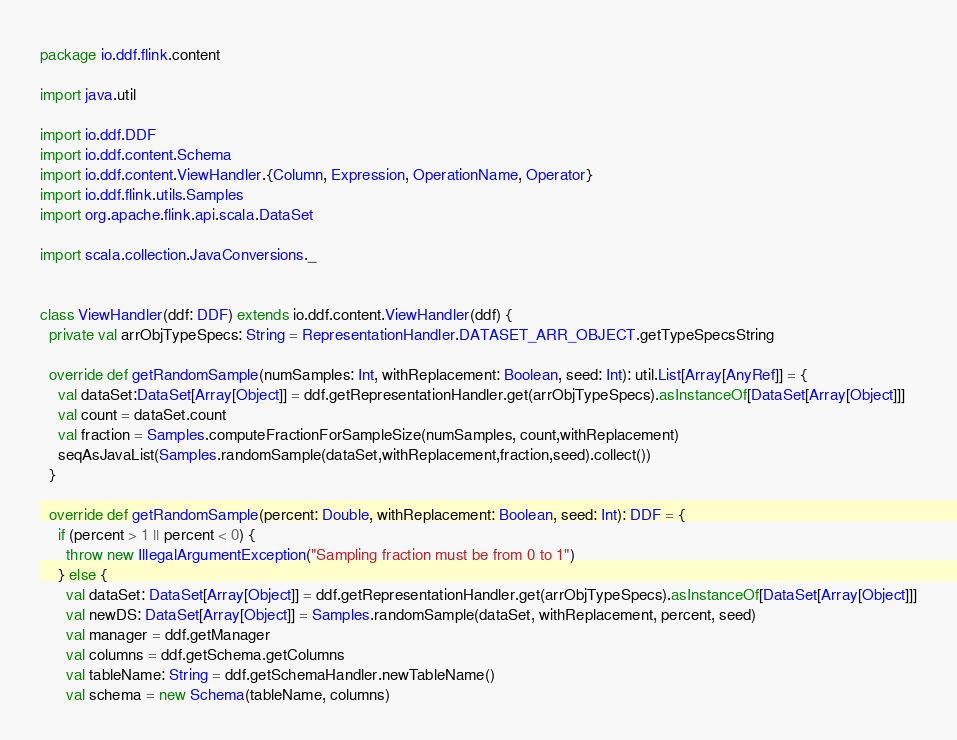<code> <loc_0><loc_0><loc_500><loc_500><_Scala_>package io.ddf.flink.content

import java.util

import io.ddf.DDF
import io.ddf.content.Schema
import io.ddf.content.ViewHandler.{Column, Expression, OperationName, Operator}
import io.ddf.flink.utils.Samples
import org.apache.flink.api.scala.DataSet

import scala.collection.JavaConversions._


class ViewHandler(ddf: DDF) extends io.ddf.content.ViewHandler(ddf) {
  private val arrObjTypeSpecs: String = RepresentationHandler.DATASET_ARR_OBJECT.getTypeSpecsString

  override def getRandomSample(numSamples: Int, withReplacement: Boolean, seed: Int): util.List[Array[AnyRef]] = {
    val dataSet:DataSet[Array[Object]] = ddf.getRepresentationHandler.get(arrObjTypeSpecs).asInstanceOf[DataSet[Array[Object]]]
    val count = dataSet.count
    val fraction = Samples.computeFractionForSampleSize(numSamples, count,withReplacement)
    seqAsJavaList(Samples.randomSample(dataSet,withReplacement,fraction,seed).collect())
  }

  override def getRandomSample(percent: Double, withReplacement: Boolean, seed: Int): DDF = {
    if (percent > 1 || percent < 0) {
      throw new IllegalArgumentException("Sampling fraction must be from 0 to 1")
    } else {
      val dataSet: DataSet[Array[Object]] = ddf.getRepresentationHandler.get(arrObjTypeSpecs).asInstanceOf[DataSet[Array[Object]]]
      val newDS: DataSet[Array[Object]] = Samples.randomSample(dataSet, withReplacement, percent, seed)
      val manager = ddf.getManager
      val columns = ddf.getSchema.getColumns
      val tableName: String = ddf.getSchemaHandler.newTableName()
      val schema = new Schema(tableName, columns)</code> 